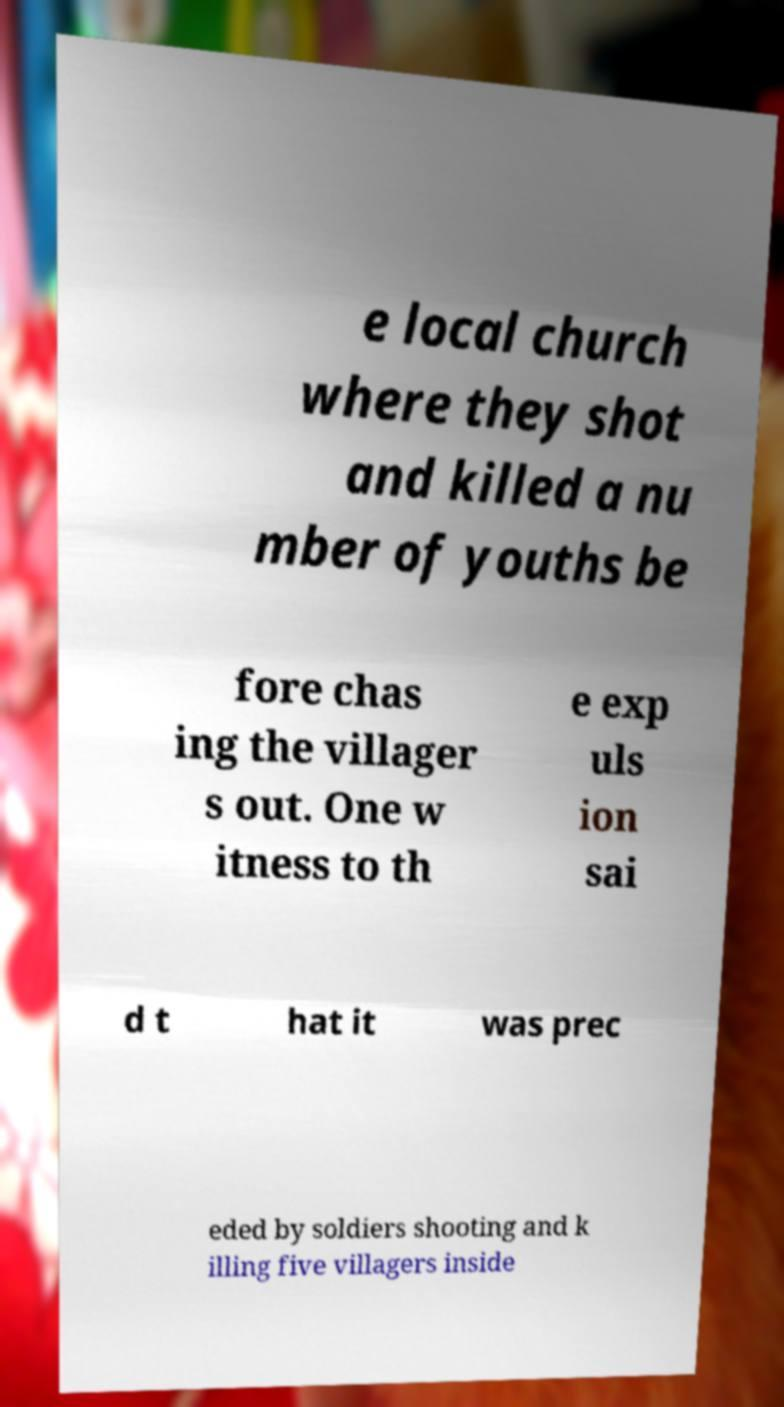Could you extract and type out the text from this image? e local church where they shot and killed a nu mber of youths be fore chas ing the villager s out. One w itness to th e exp uls ion sai d t hat it was prec eded by soldiers shooting and k illing five villagers inside 